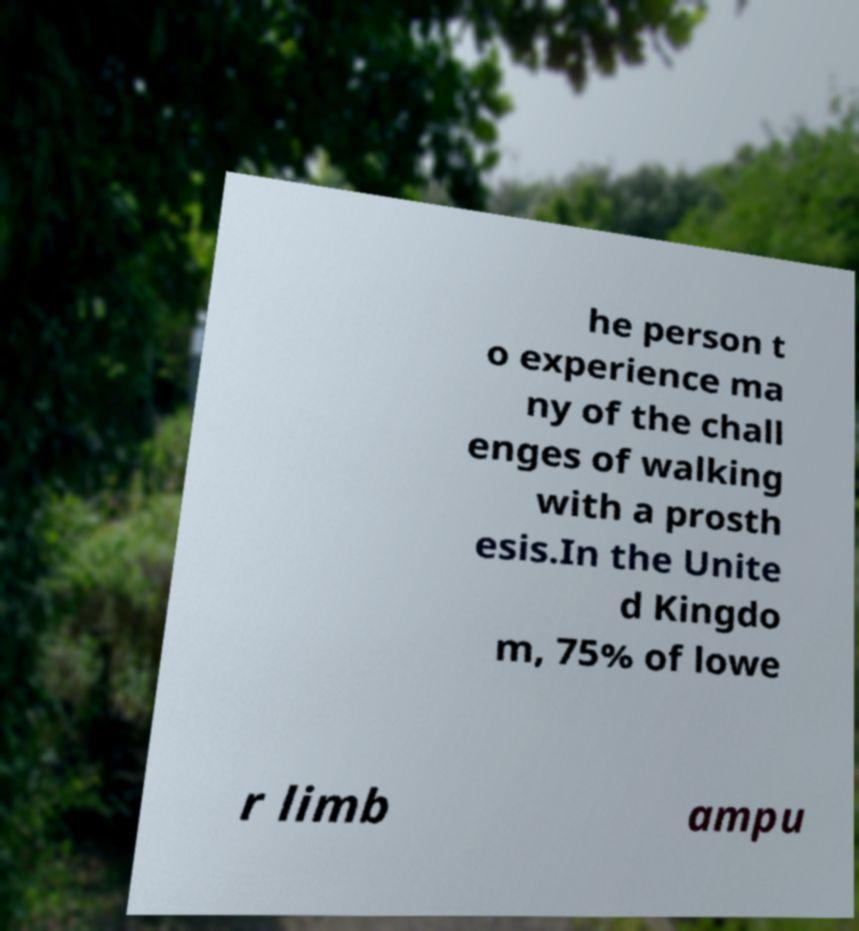Can you accurately transcribe the text from the provided image for me? he person t o experience ma ny of the chall enges of walking with a prosth esis.In the Unite d Kingdo m, 75% of lowe r limb ampu 